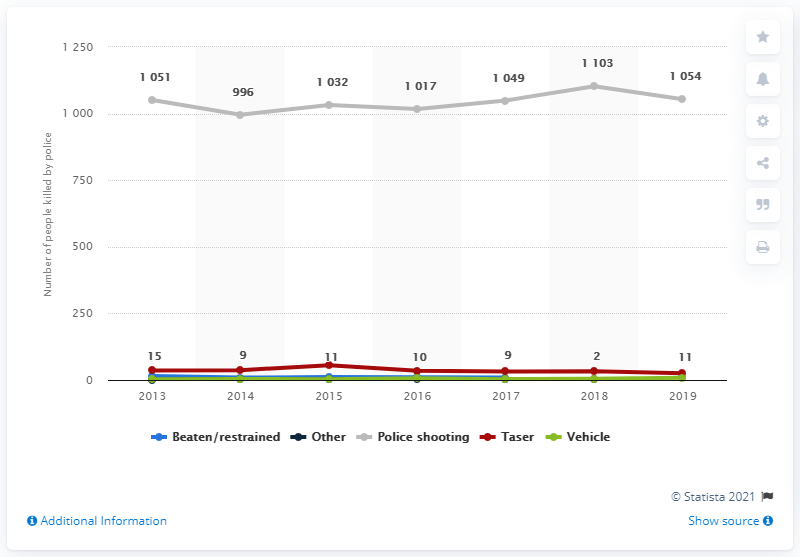Highlight a few significant elements in this photo. In 2019, it is reported that 11 people were killed as a result of being beaten or restrained by police. 